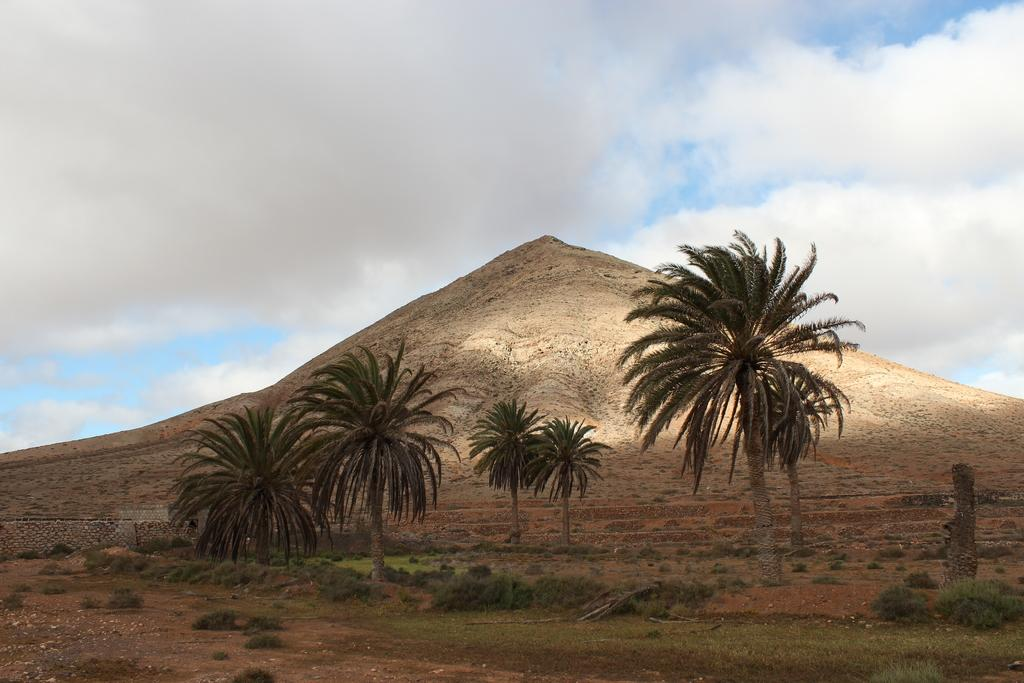What type of vegetation can be seen in the image? There are trees, plants, and grass in the image. What type of natural feature is present in the image? There is a mountain in the image. What type of man-made structure can be seen in the image? There is a stone wall in the image. What is visible in the sky in the image? There are clouds in the sky in the image. What degree of control does the mountain have over the clouds in the image? The mountain does not have any control over the clouds in the image; they are separate natural phenomena. What is the mouth of the mountain doing in the image? There is no mouth present on the mountain in the image, as mountains are inanimate natural features. 